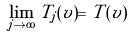Convert formula to latex. <formula><loc_0><loc_0><loc_500><loc_500>\lim _ { j \to \infty } T _ { j } ( v ) = T ( v )</formula> 